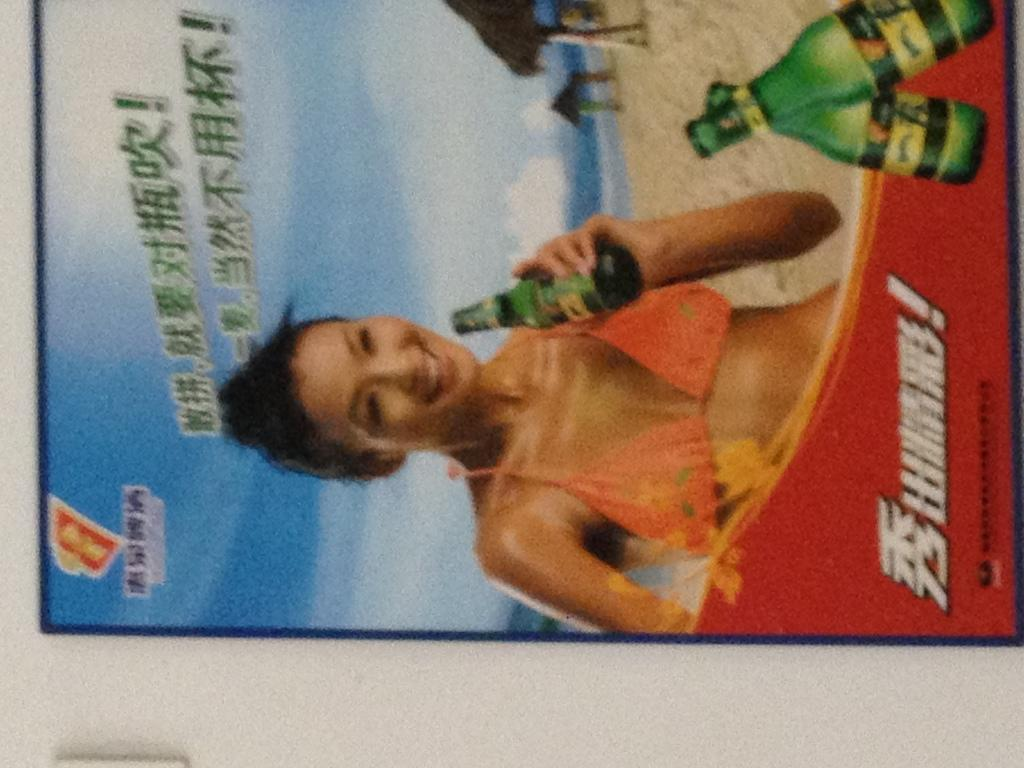What can be seen hanging on the wall in the image? There is a poster in the image. How many cents are depicted on the poster in the image? There are no cents visible on the poster in the image. What type of structure is shown in the background of the poster? The provided facts do not mention any structure in the background of the poster, so it cannot be determined from the image. 